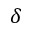Convert formula to latex. <formula><loc_0><loc_0><loc_500><loc_500>\delta</formula> 